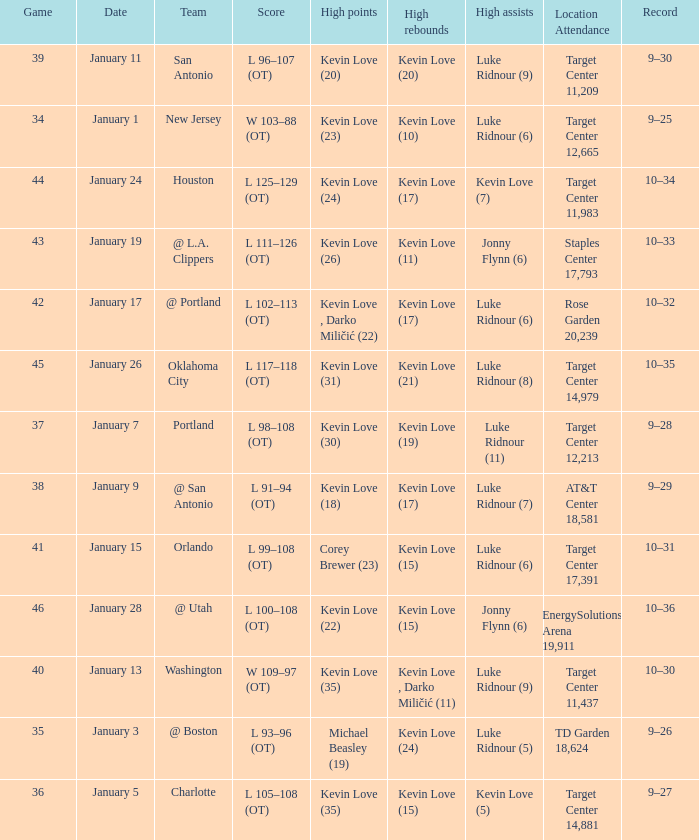What is the date for the game 35? January 3. 